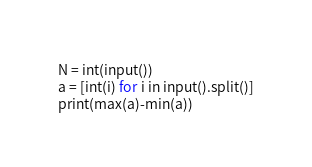Convert code to text. <code><loc_0><loc_0><loc_500><loc_500><_Python_>N = int(input())
a = [int(i) for i in input().split()]
print(max(a)-min(a))
</code> 